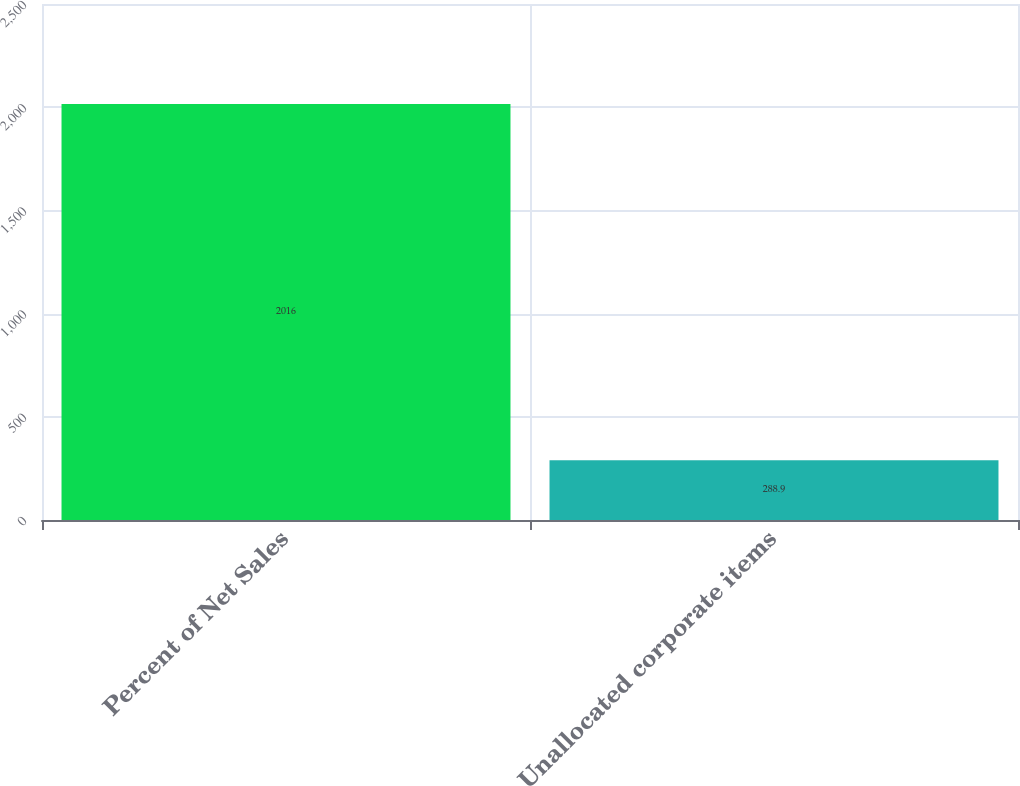Convert chart to OTSL. <chart><loc_0><loc_0><loc_500><loc_500><bar_chart><fcel>Percent of Net Sales<fcel>Unallocated corporate items<nl><fcel>2016<fcel>288.9<nl></chart> 